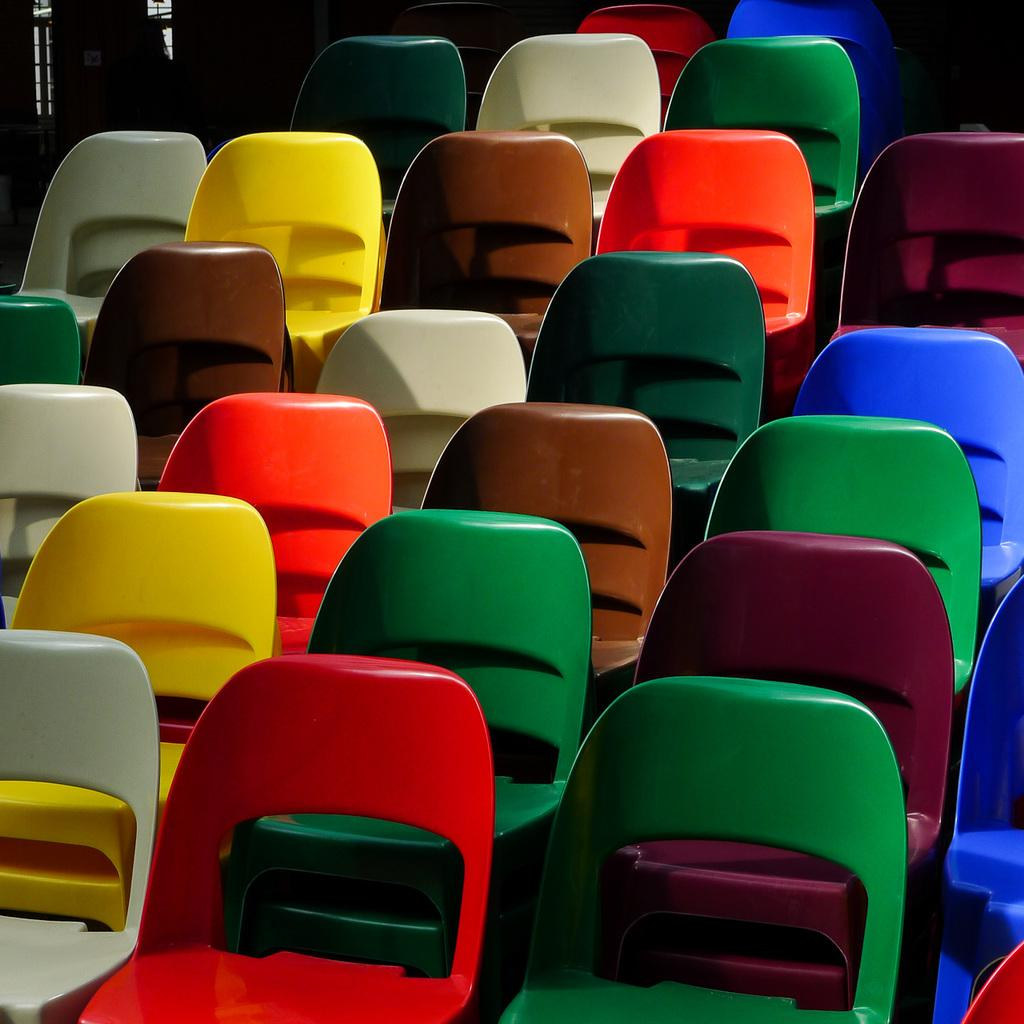What type of furniture can be seen in the image? Chairs can be seen in the image. What type of record is being played on the selection of chairs in the image? There is no record or selection of chairs present in the image; it only shows chairs. 